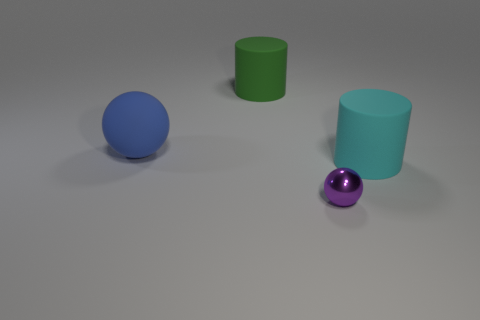Is there any other thing that has the same material as the tiny object?
Provide a short and direct response. No. How many green objects are on the right side of the ball behind the big cyan cylinder in front of the large green cylinder?
Provide a succinct answer. 1. What is the size of the purple metal thing that is the same shape as the large blue rubber object?
Keep it short and to the point. Small. Is there anything else that has the same size as the blue ball?
Your answer should be very brief. Yes. Is the material of the large cylinder that is in front of the big blue sphere the same as the tiny object?
Keep it short and to the point. No. What color is the other rubber object that is the same shape as the big cyan matte thing?
Offer a terse response. Green. How many other objects are the same color as the tiny metallic object?
Keep it short and to the point. 0. Does the large matte object that is right of the large green rubber cylinder have the same shape as the large rubber thing on the left side of the green object?
Keep it short and to the point. No. How many balls are cyan things or blue things?
Provide a succinct answer. 1. Are there fewer big green matte things that are in front of the purple thing than metallic objects?
Your response must be concise. Yes. 